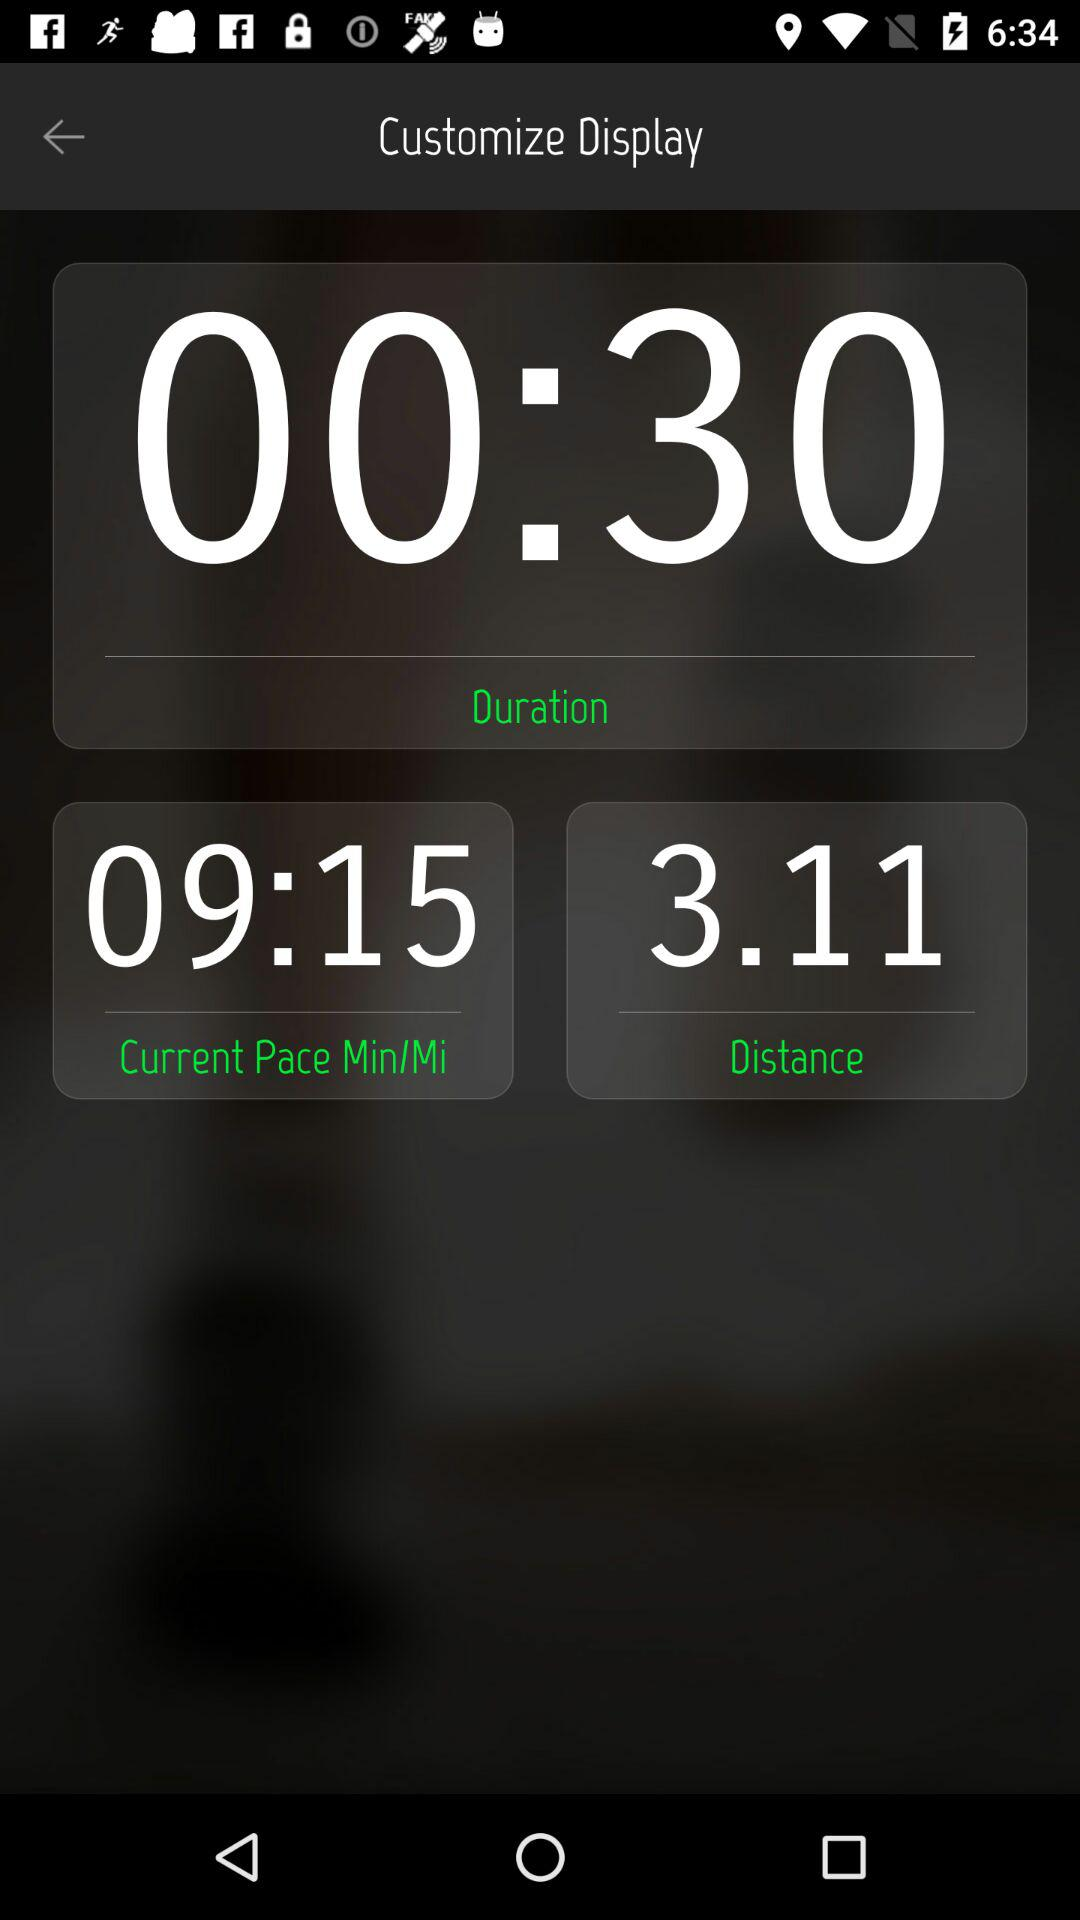How long is the duration of this run?
Answer the question using a single word or phrase. 00:30 